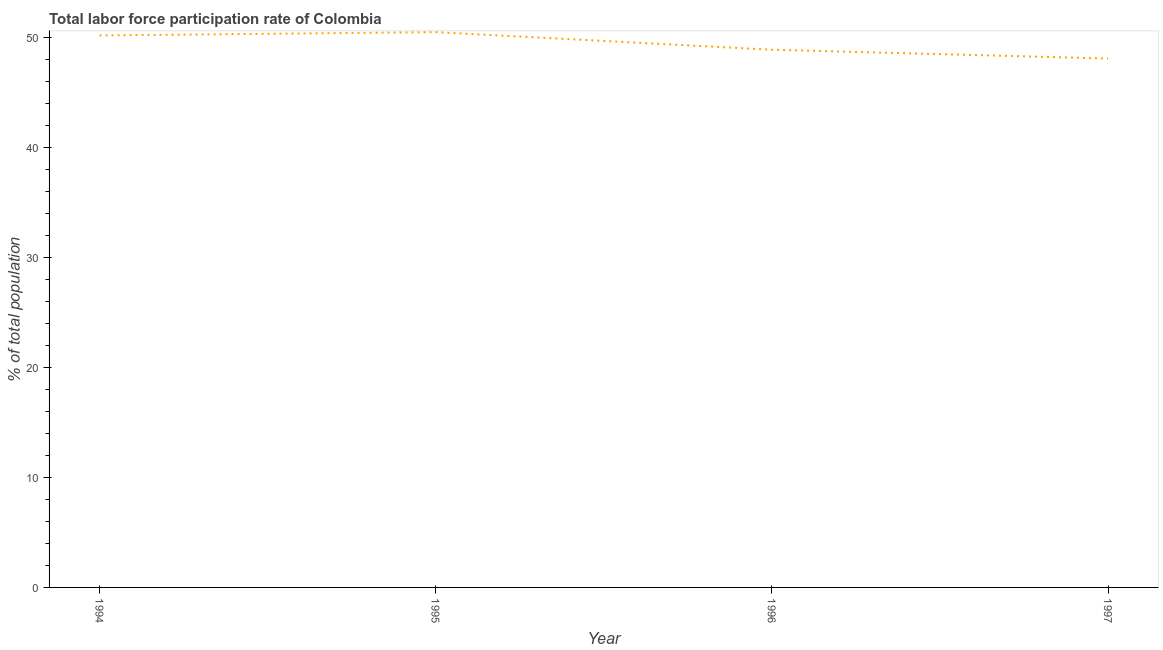What is the total labor force participation rate in 1995?
Make the answer very short. 50.5. Across all years, what is the maximum total labor force participation rate?
Provide a succinct answer. 50.5. Across all years, what is the minimum total labor force participation rate?
Your answer should be very brief. 48.1. In which year was the total labor force participation rate maximum?
Ensure brevity in your answer.  1995. What is the sum of the total labor force participation rate?
Offer a very short reply. 197.7. What is the difference between the total labor force participation rate in 1994 and 1996?
Your response must be concise. 1.3. What is the average total labor force participation rate per year?
Provide a short and direct response. 49.43. What is the median total labor force participation rate?
Your response must be concise. 49.55. What is the ratio of the total labor force participation rate in 1996 to that in 1997?
Offer a terse response. 1.02. Is the total labor force participation rate in 1996 less than that in 1997?
Keep it short and to the point. No. What is the difference between the highest and the second highest total labor force participation rate?
Ensure brevity in your answer.  0.3. What is the difference between the highest and the lowest total labor force participation rate?
Provide a succinct answer. 2.4. Does the total labor force participation rate monotonically increase over the years?
Offer a very short reply. No. How many years are there in the graph?
Provide a short and direct response. 4. What is the difference between two consecutive major ticks on the Y-axis?
Your answer should be very brief. 10. Does the graph contain grids?
Ensure brevity in your answer.  No. What is the title of the graph?
Give a very brief answer. Total labor force participation rate of Colombia. What is the label or title of the X-axis?
Give a very brief answer. Year. What is the label or title of the Y-axis?
Ensure brevity in your answer.  % of total population. What is the % of total population of 1994?
Your response must be concise. 50.2. What is the % of total population of 1995?
Offer a terse response. 50.5. What is the % of total population of 1996?
Keep it short and to the point. 48.9. What is the % of total population in 1997?
Give a very brief answer. 48.1. What is the difference between the % of total population in 1994 and 1995?
Give a very brief answer. -0.3. What is the difference between the % of total population in 1996 and 1997?
Your answer should be very brief. 0.8. What is the ratio of the % of total population in 1994 to that in 1995?
Your response must be concise. 0.99. What is the ratio of the % of total population in 1994 to that in 1996?
Offer a terse response. 1.03. What is the ratio of the % of total population in 1994 to that in 1997?
Give a very brief answer. 1.04. What is the ratio of the % of total population in 1995 to that in 1996?
Give a very brief answer. 1.03. 